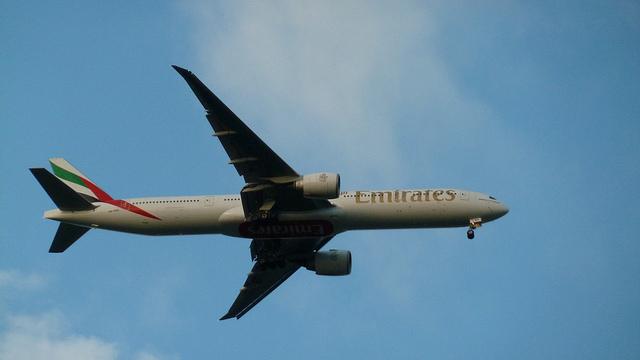Is the plane in the air?
Short answer required. Yes. Is this plane taking off or landing?
Concise answer only. Landing. What does the plane say?
Short answer required. Emirates. How many colors are visible on the plane?
Short answer required. 4. 